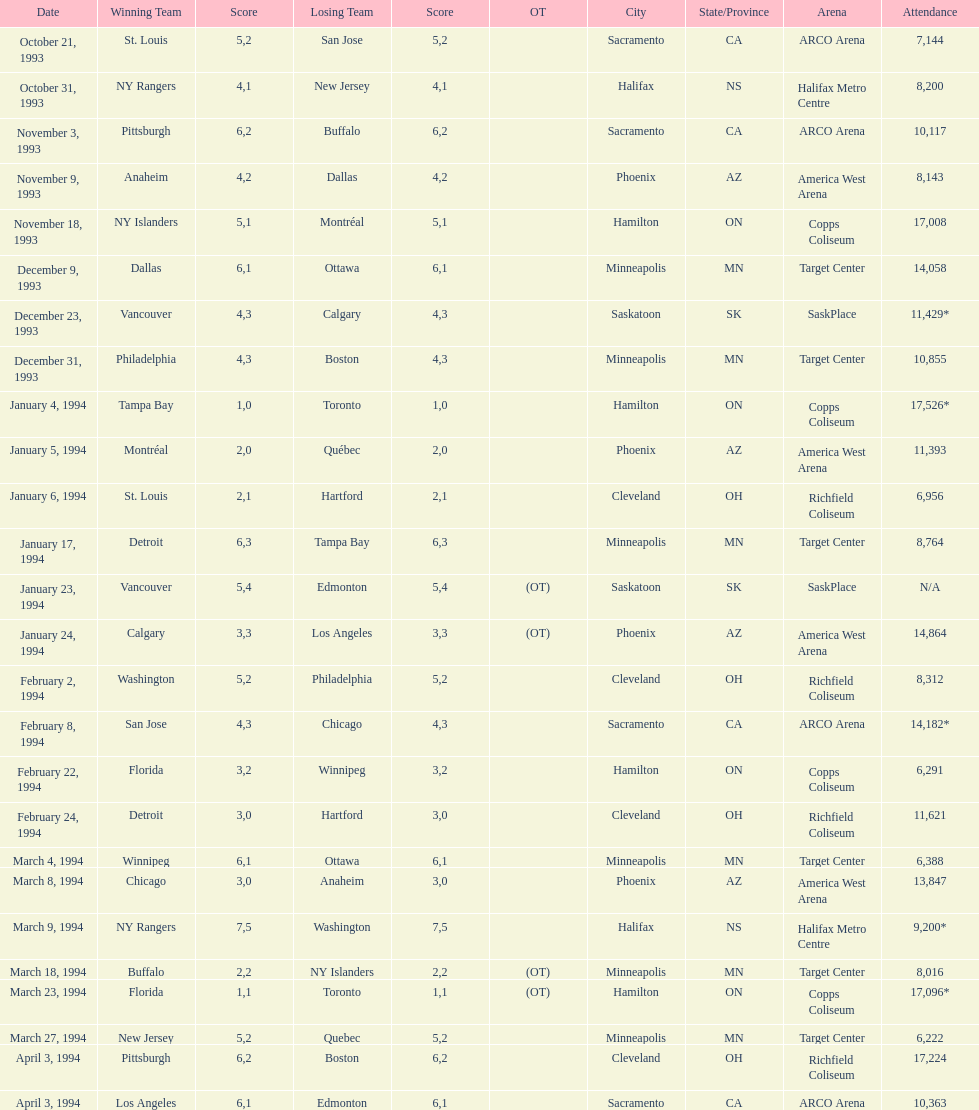The game on which date had the most attendance? January 4, 1994. 